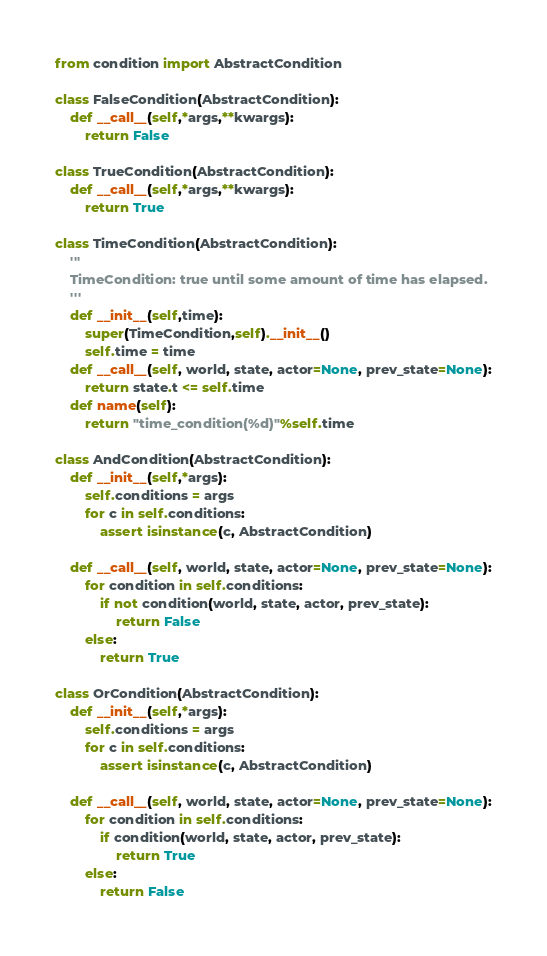Convert code to text. <code><loc_0><loc_0><loc_500><loc_500><_Python_>from condition import AbstractCondition

class FalseCondition(AbstractCondition):
    def __call__(self,*args,**kwargs):
        return False

class TrueCondition(AbstractCondition):
    def __call__(self,*args,**kwargs):
        return True

class TimeCondition(AbstractCondition):
    '''
    TimeCondition: true until some amount of time has elapsed.
    '''
    def __init__(self,time):
        super(TimeCondition,self).__init__()
        self.time = time
    def __call__(self, world, state, actor=None, prev_state=None):
        return state.t <= self.time
    def name(self):
        return "time_condition(%d)"%self.time

class AndCondition(AbstractCondition):
    def __init__(self,*args):
        self.conditions = args
        for c in self.conditions:
            assert isinstance(c, AbstractCondition)

    def __call__(self, world, state, actor=None, prev_state=None):
        for condition in self.conditions:
            if not condition(world, state, actor, prev_state):
                return False
        else:
            return True

class OrCondition(AbstractCondition):
    def __init__(self,*args):
        self.conditions = args
        for c in self.conditions:
            assert isinstance(c, AbstractCondition)

    def __call__(self, world, state, actor=None, prev_state=None):
        for condition in self.conditions:
            if condition(world, state, actor, prev_state):
                return True
        else:
            return False

</code> 